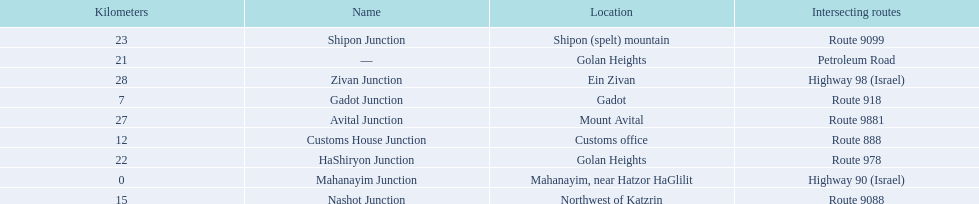What are all the are all the locations on the highway 91 (israel)? Mahanayim, near Hatzor HaGlilit, Gadot, Customs office, Northwest of Katzrin, Golan Heights, Golan Heights, Shipon (spelt) mountain, Mount Avital, Ein Zivan. What are the distance values in kilometers for ein zivan, gadot junction and shipon junction? 7, 23, 28. Which is the least distance away? 7. What is the name? Gadot Junction. 